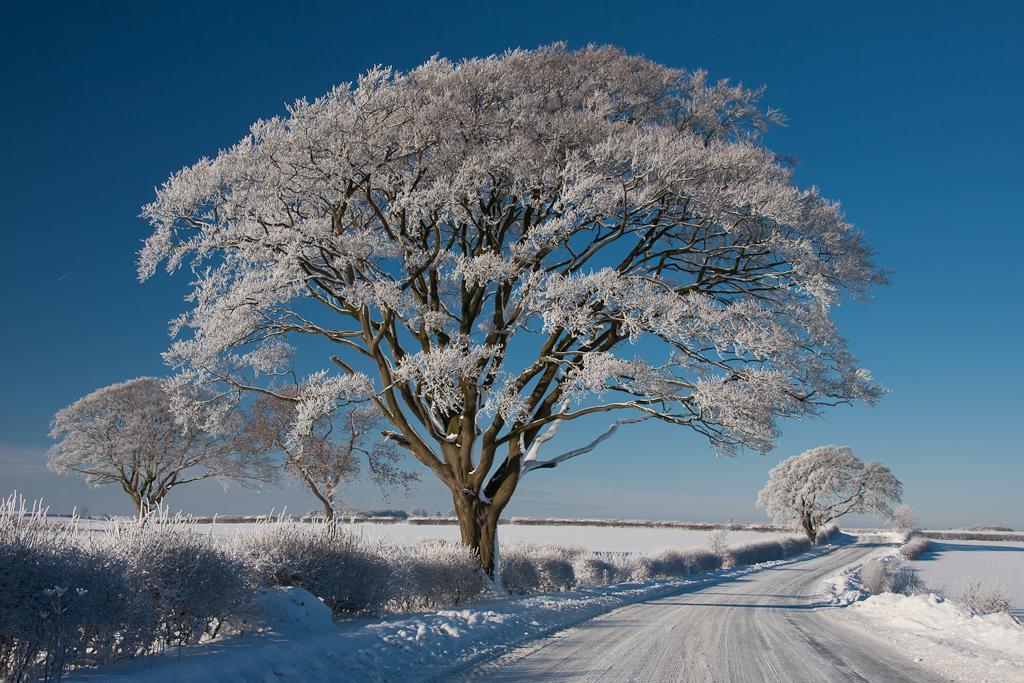Could you give a brief overview of what you see in this image? In this image, we can see trees and plants are covered by snow and at the bottom, there is a road and snow. 